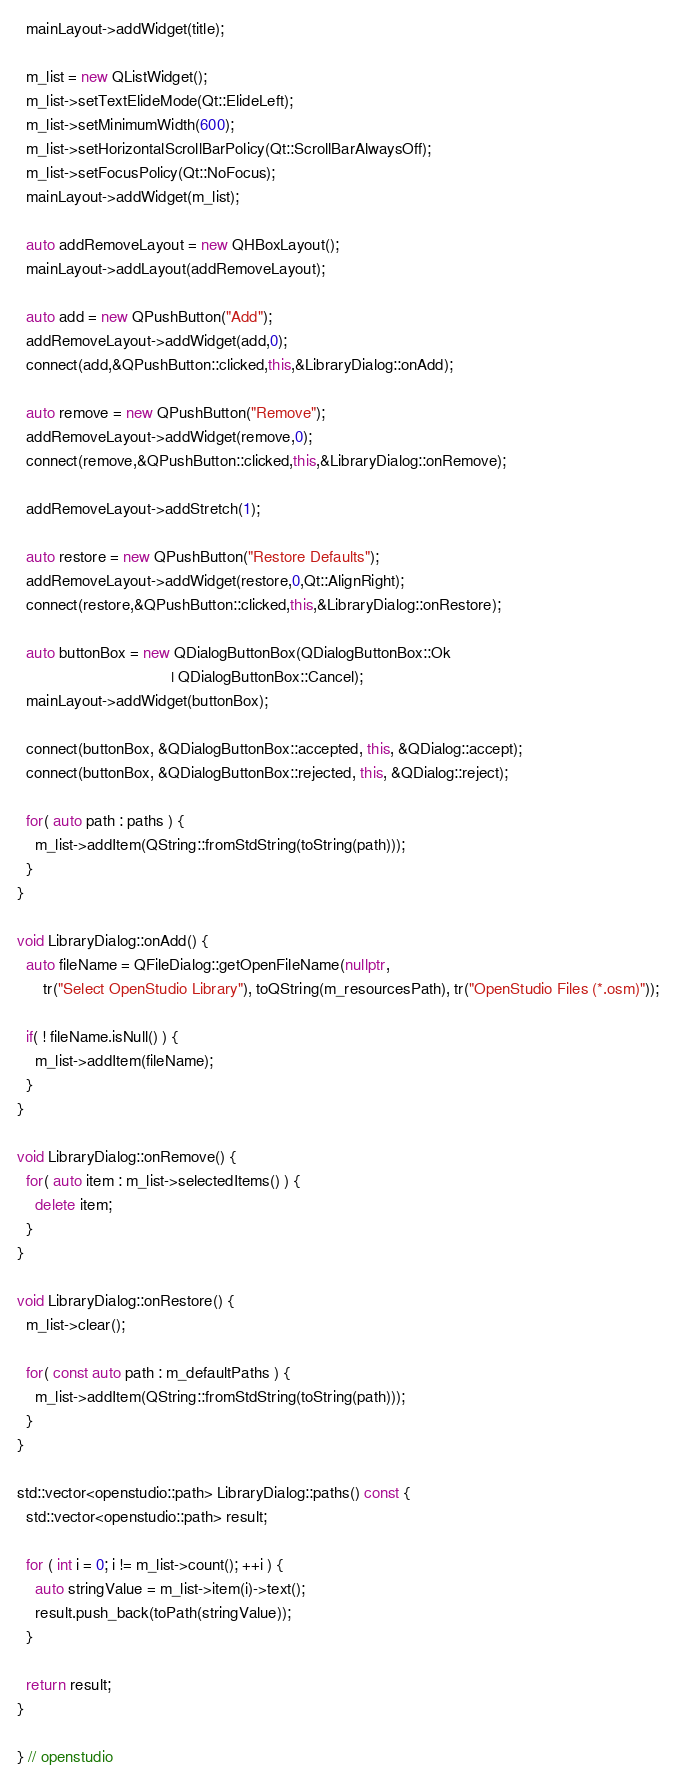<code> <loc_0><loc_0><loc_500><loc_500><_C++_>  mainLayout->addWidget(title);

  m_list = new QListWidget();
  m_list->setTextElideMode(Qt::ElideLeft);
  m_list->setMinimumWidth(600);
  m_list->setHorizontalScrollBarPolicy(Qt::ScrollBarAlwaysOff);
  m_list->setFocusPolicy(Qt::NoFocus);
  mainLayout->addWidget(m_list);

  auto addRemoveLayout = new QHBoxLayout();
  mainLayout->addLayout(addRemoveLayout);

  auto add = new QPushButton("Add");
  addRemoveLayout->addWidget(add,0);
  connect(add,&QPushButton::clicked,this,&LibraryDialog::onAdd);

  auto remove = new QPushButton("Remove");
  addRemoveLayout->addWidget(remove,0);
  connect(remove,&QPushButton::clicked,this,&LibraryDialog::onRemove);

  addRemoveLayout->addStretch(1);

  auto restore = new QPushButton("Restore Defaults");
  addRemoveLayout->addWidget(restore,0,Qt::AlignRight);
  connect(restore,&QPushButton::clicked,this,&LibraryDialog::onRestore);

  auto buttonBox = new QDialogButtonBox(QDialogButtonBox::Ok
                                   | QDialogButtonBox::Cancel);
  mainLayout->addWidget(buttonBox);

  connect(buttonBox, &QDialogButtonBox::accepted, this, &QDialog::accept);
  connect(buttonBox, &QDialogButtonBox::rejected, this, &QDialog::reject);

  for( auto path : paths ) {
    m_list->addItem(QString::fromStdString(toString(path)));
  }
}

void LibraryDialog::onAdd() {
  auto fileName = QFileDialog::getOpenFileName(nullptr,
      tr("Select OpenStudio Library"), toQString(m_resourcesPath), tr("OpenStudio Files (*.osm)"));

  if( ! fileName.isNull() ) {
    m_list->addItem(fileName);
  }
}

void LibraryDialog::onRemove() {
  for( auto item : m_list->selectedItems() ) {
    delete item;
  }
}

void LibraryDialog::onRestore() {
  m_list->clear();

  for( const auto path : m_defaultPaths ) {
    m_list->addItem(QString::fromStdString(toString(path)));
  }
}

std::vector<openstudio::path> LibraryDialog::paths() const {
  std::vector<openstudio::path> result;

  for ( int i = 0; i != m_list->count(); ++i ) {
    auto stringValue = m_list->item(i)->text();
    result.push_back(toPath(stringValue));
  }

  return result;
}

} // openstudio

</code> 